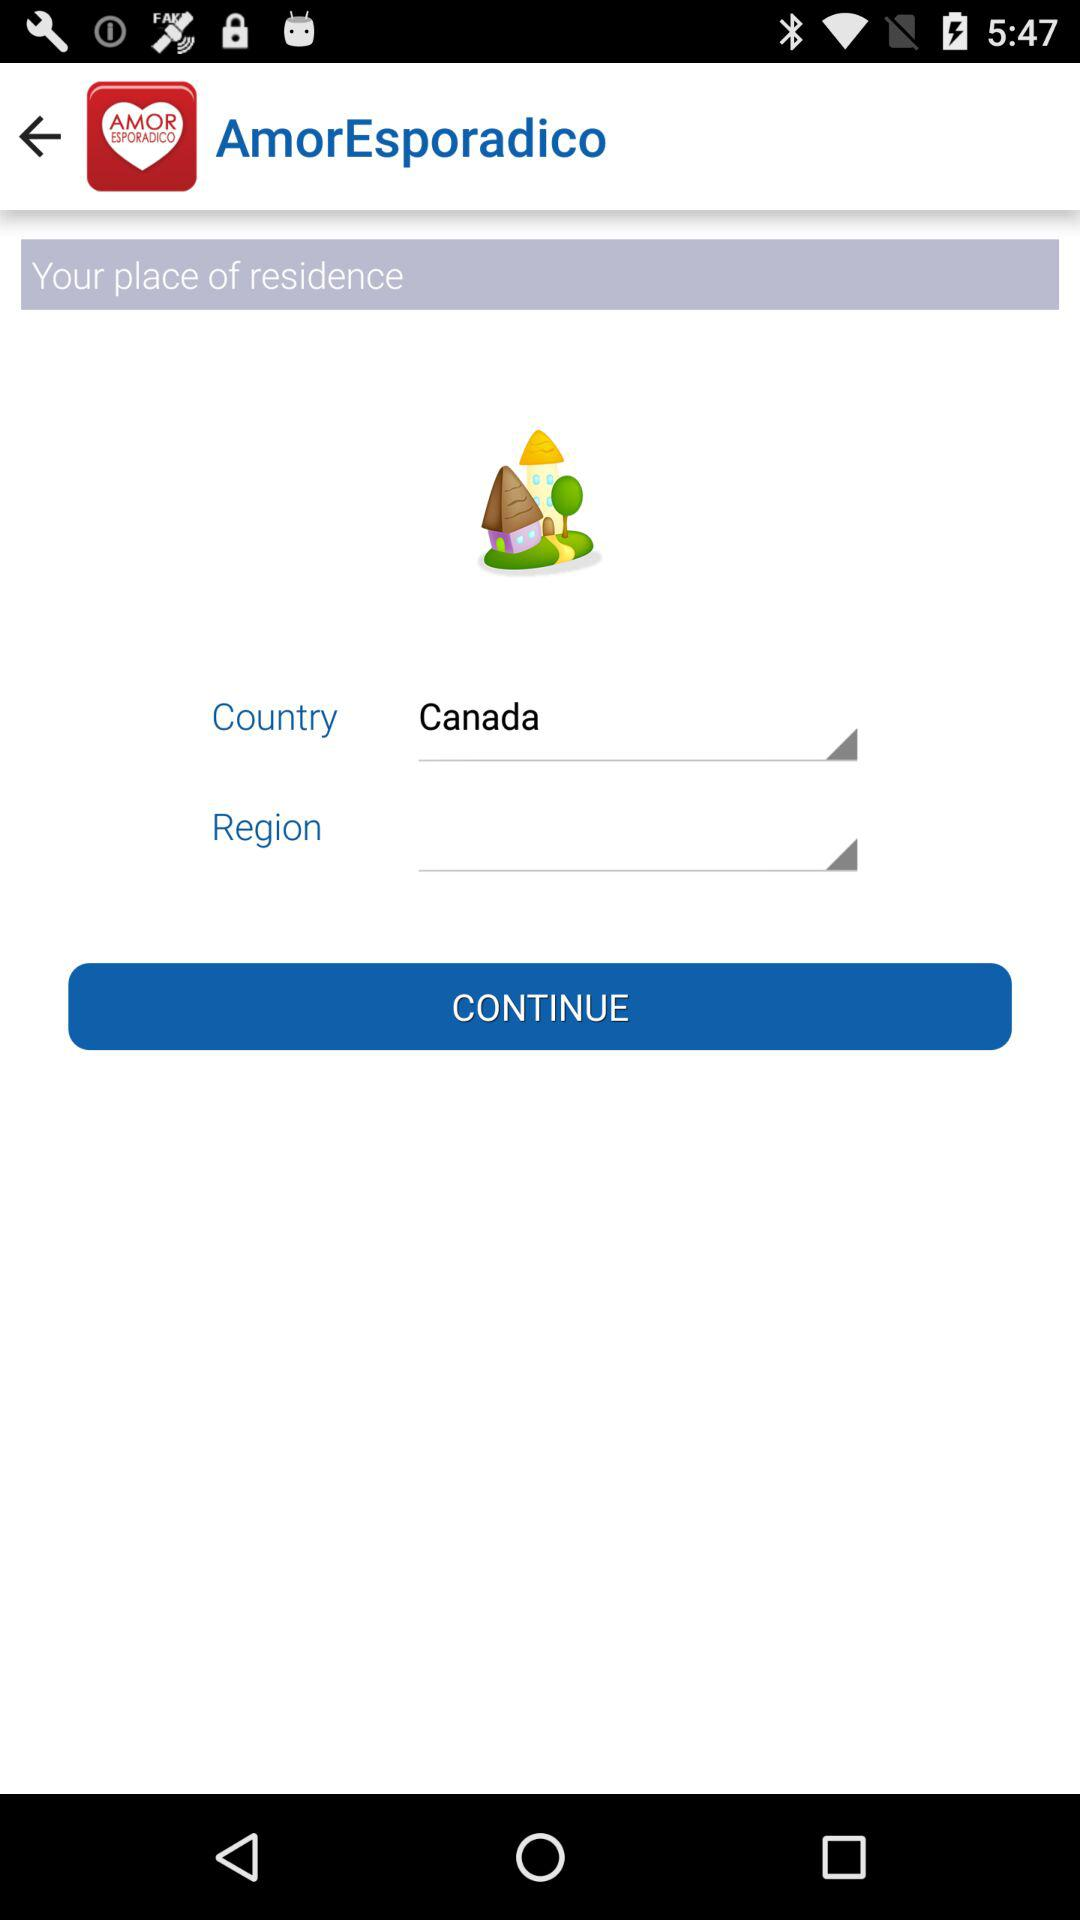Which region is selected?
When the provided information is insufficient, respond with <no answer>. <no answer> 